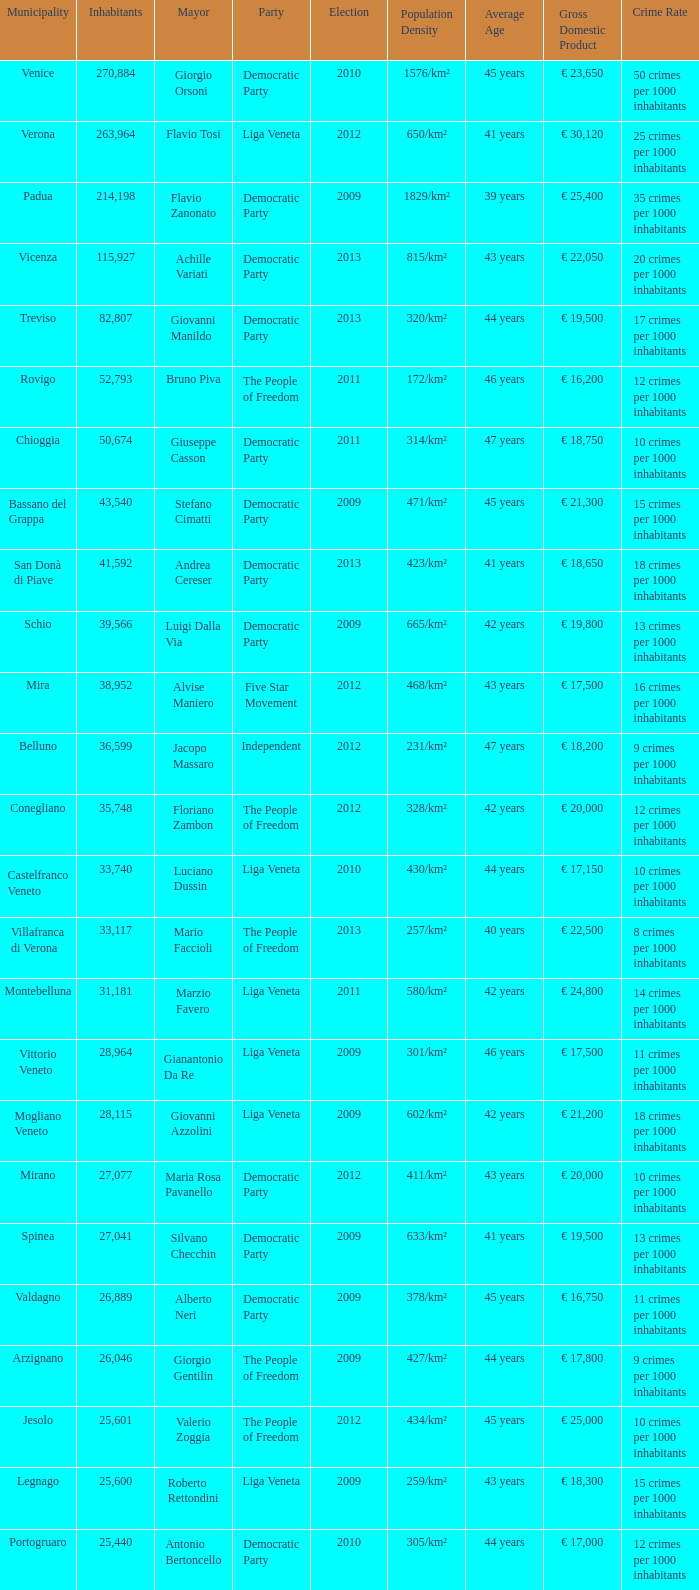In the election earlier than 2012 how many Inhabitants had a Party of five star movement? None. 